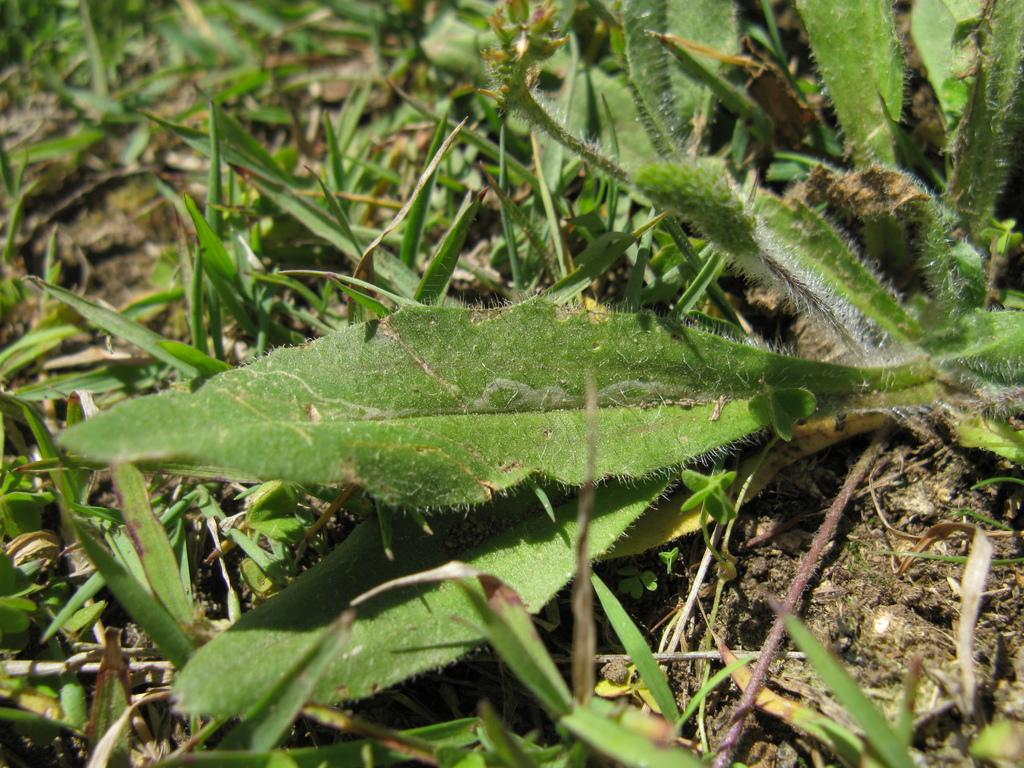What type of vegetation is present in the image? There are grass plants in the image. Can you see a giraffe eating the grass in the image? There is no giraffe present in the image, and therefore no such activity can be observed. 